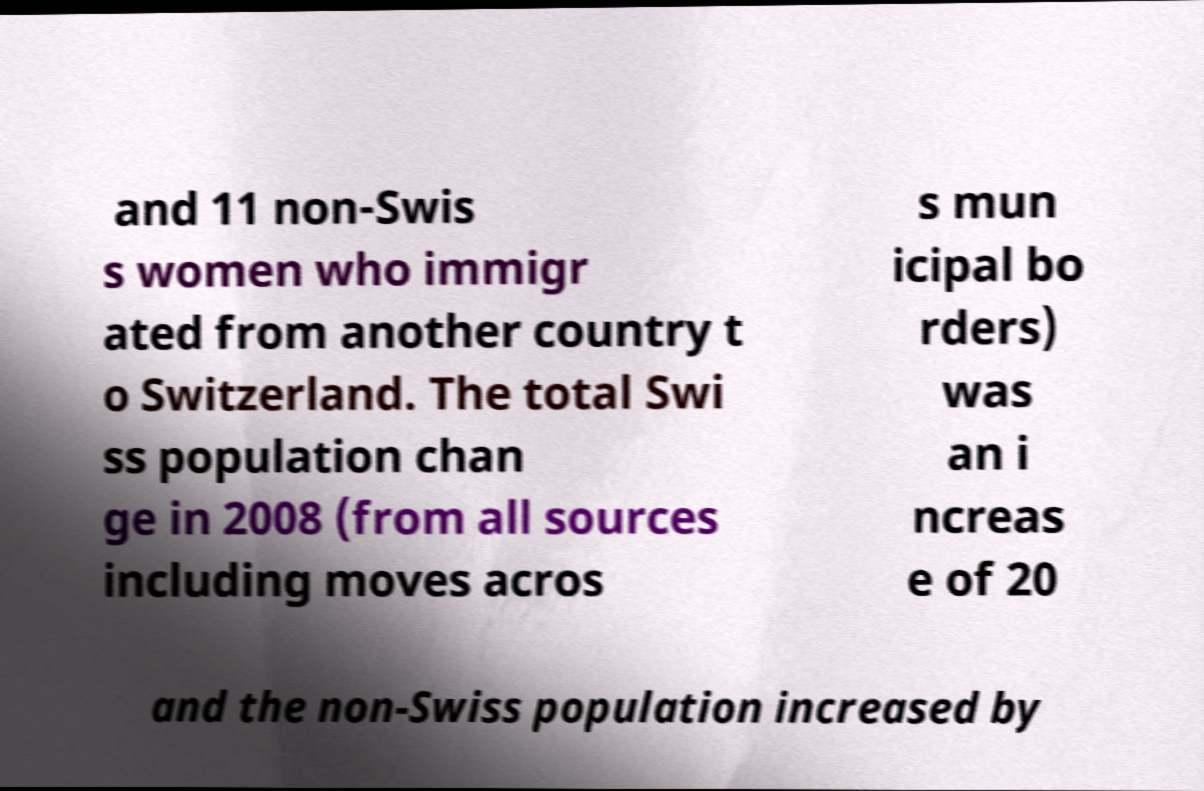For documentation purposes, I need the text within this image transcribed. Could you provide that? and 11 non-Swis s women who immigr ated from another country t o Switzerland. The total Swi ss population chan ge in 2008 (from all sources including moves acros s mun icipal bo rders) was an i ncreas e of 20 and the non-Swiss population increased by 